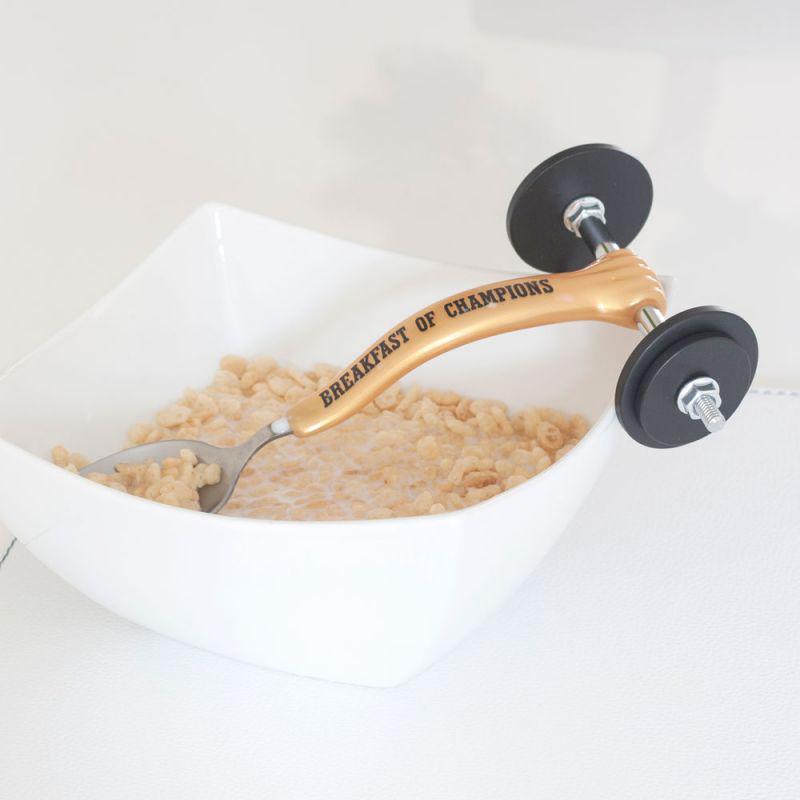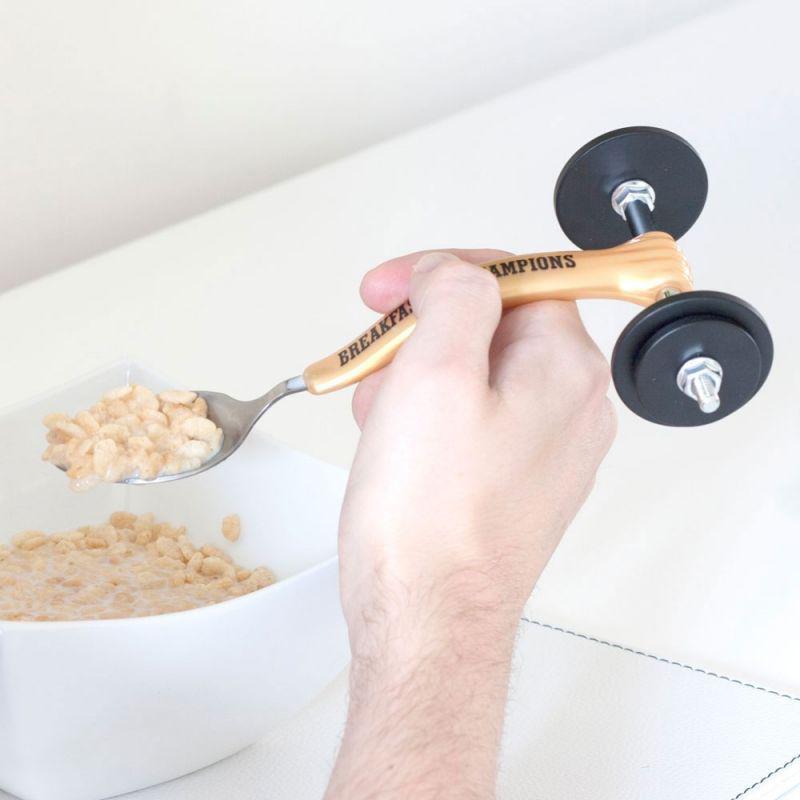The first image is the image on the left, the second image is the image on the right. Given the left and right images, does the statement "In one image, a fancy spoon with wheels is held in a hand." hold true? Answer yes or no. Yes. The first image is the image on the left, the second image is the image on the right. For the images shown, is this caption "there is a hand in one of the images" true? Answer yes or no. Yes. 